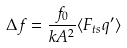Convert formula to latex. <formula><loc_0><loc_0><loc_500><loc_500>\Delta f = \frac { f _ { 0 } } { k A ^ { 2 } } \langle F _ { t s } q ^ { \prime } \rangle</formula> 